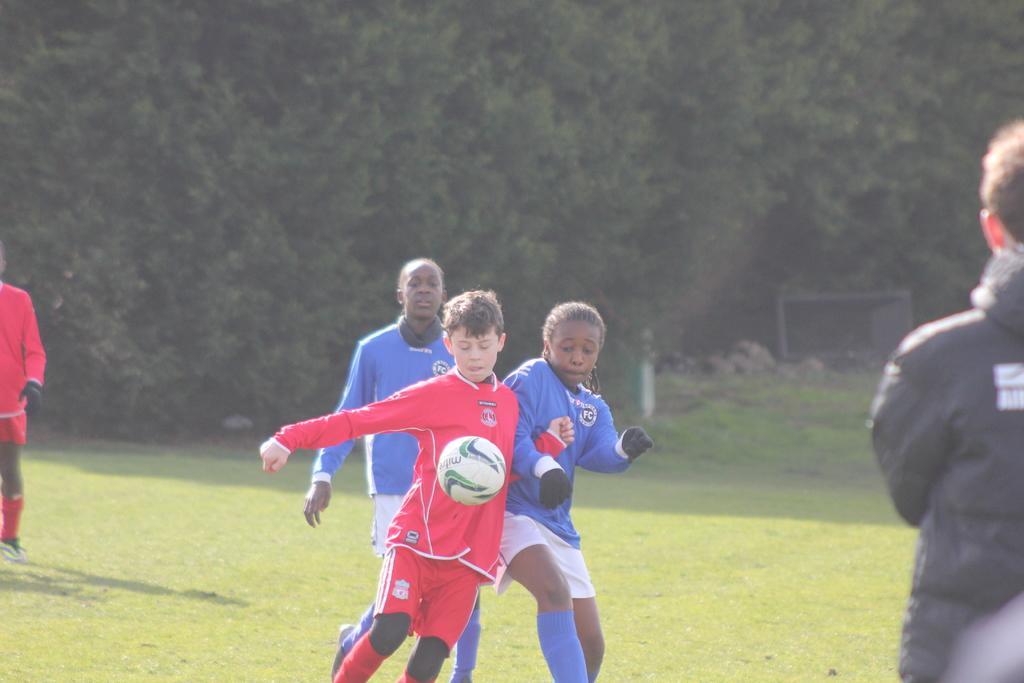Please provide a concise description of this image. In the image we can see there are three kids who are in the middle of the image they are playing football and on the ground it's covered with grass. There are lot of trees behind, there are two more kids who are at the corners of the image. 